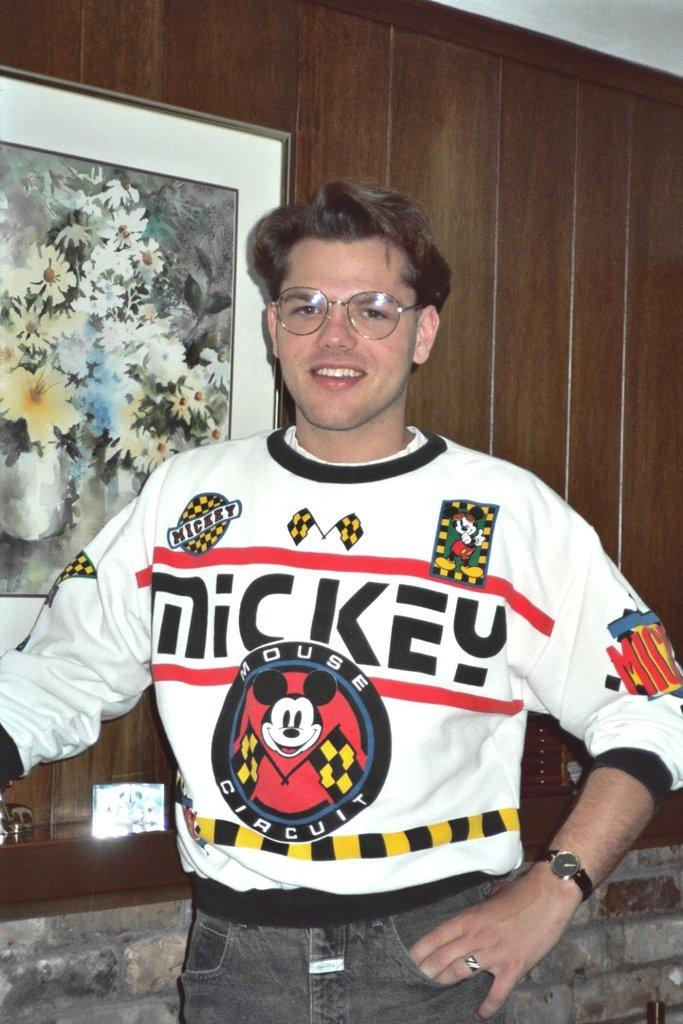<image>
Describe the image concisely. A man is wearing a sweatshirt with a picture of Mickey Mouse and the words Mickey printed in large print. 